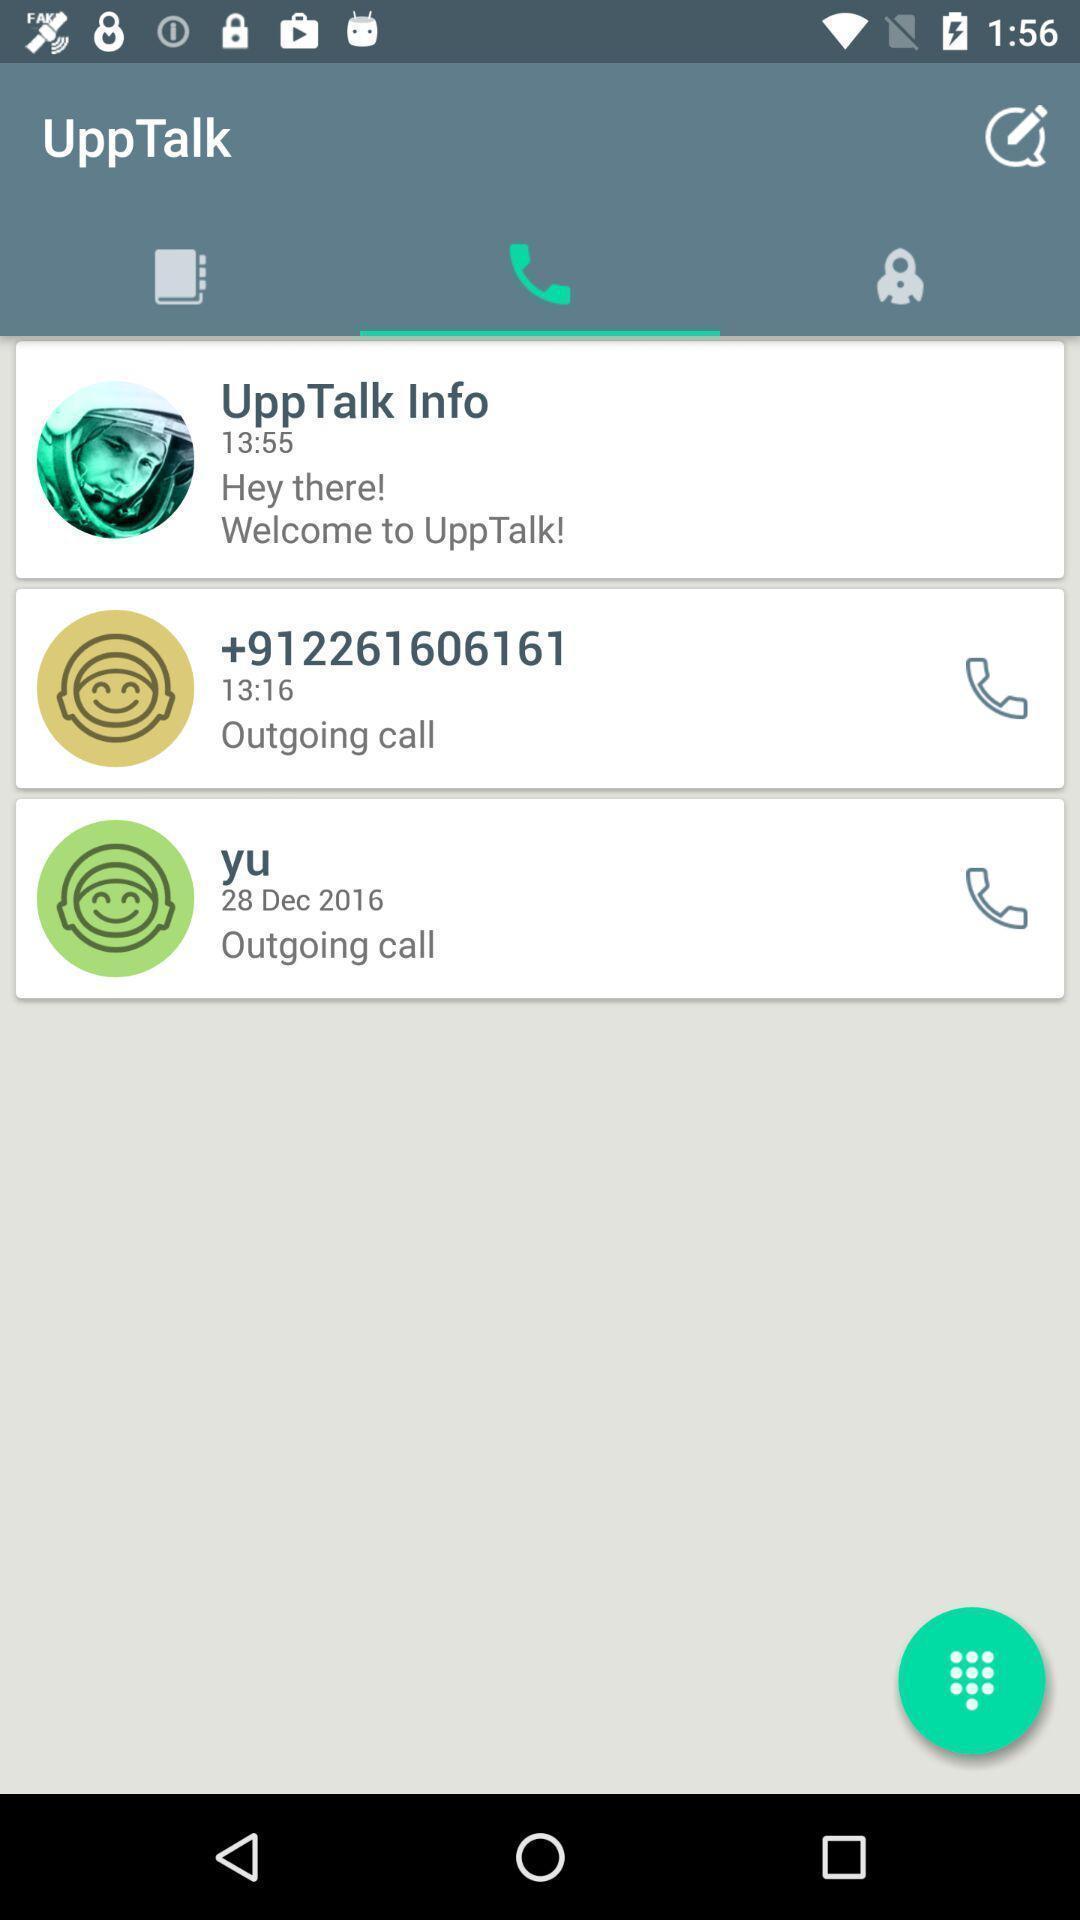Explain the elements present in this screenshot. Screen displaying outgoing calls. 